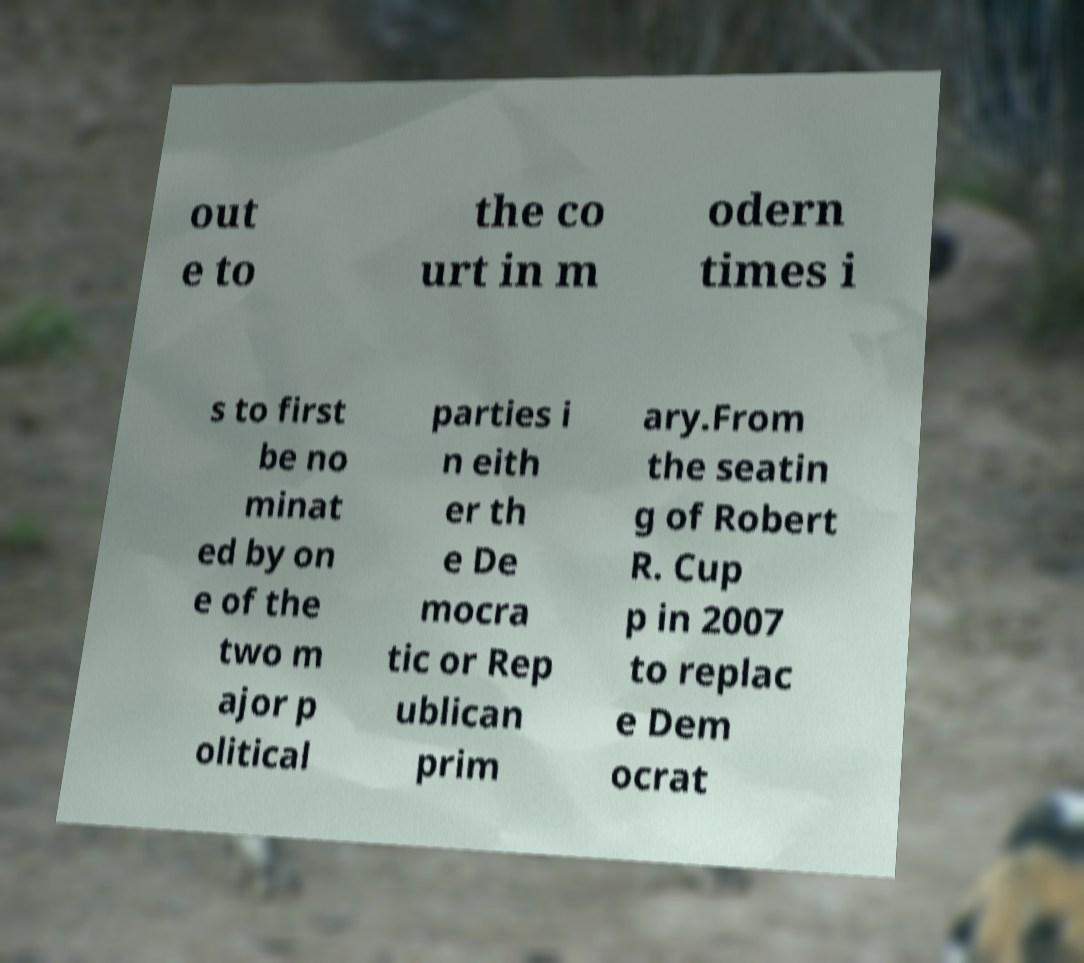Can you accurately transcribe the text from the provided image for me? out e to the co urt in m odern times i s to first be no minat ed by on e of the two m ajor p olitical parties i n eith er th e De mocra tic or Rep ublican prim ary.From the seatin g of Robert R. Cup p in 2007 to replac e Dem ocrat 